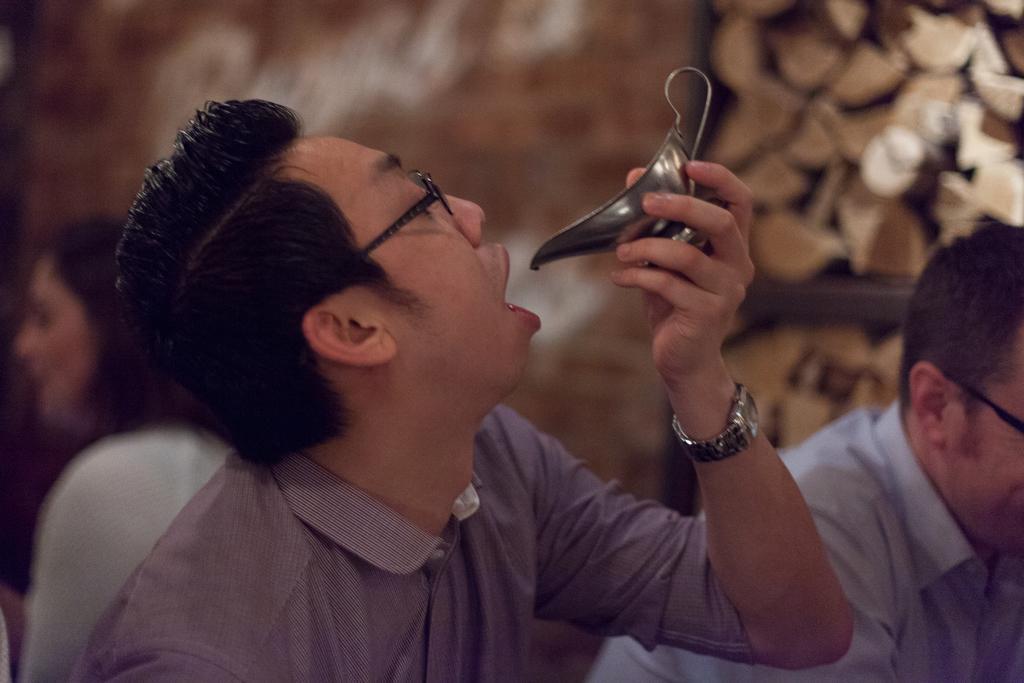In one or two sentences, can you explain what this image depicts? In this image I can see a person wearing watch and shirt is holding utensil in his hand. In the background I can see few other persons and the blurry background. 